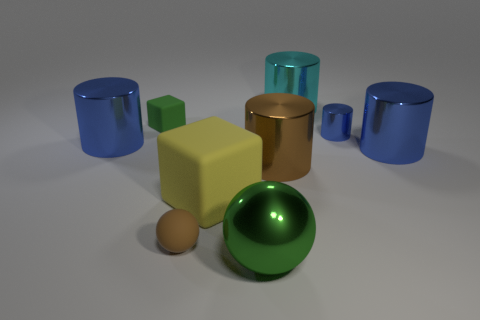Are there more cyan objects than small rubber things?
Provide a succinct answer. No. There is a metal object behind the small green object; what is its color?
Provide a short and direct response. Cyan. Is the number of cubes that are right of the cyan thing greater than the number of small blue objects?
Offer a terse response. No. Is the material of the big ball the same as the tiny green object?
Your answer should be very brief. No. What number of other things are there of the same shape as the big yellow object?
Your answer should be very brief. 1. Is there anything else that is made of the same material as the small sphere?
Your answer should be very brief. Yes. What is the color of the tiny rubber object that is behind the big blue object that is right of the blue shiny object on the left side of the green shiny object?
Give a very brief answer. Green. There is a big blue shiny object that is right of the brown matte ball; does it have the same shape as the large green metal thing?
Your answer should be very brief. No. What number of tiny matte objects are there?
Your answer should be very brief. 2. How many metal objects have the same size as the metallic ball?
Provide a succinct answer. 4. 